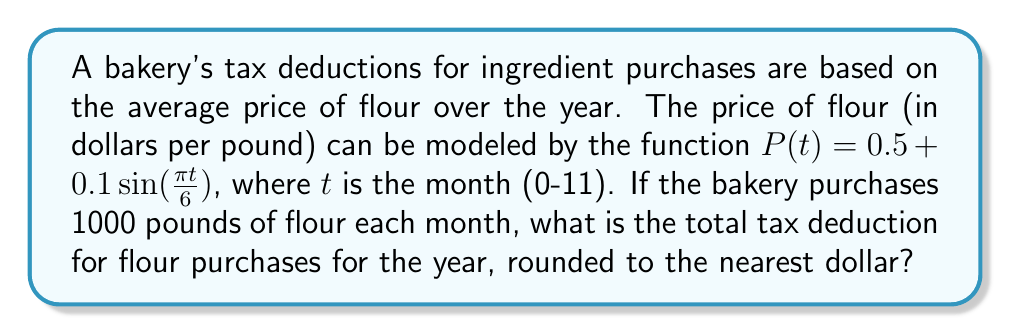What is the answer to this math problem? To solve this problem, we need to follow these steps:

1) First, we need to calculate the average price of flour over the year:
   $$\text{Average Price} = \frac{1}{12}\sum_{t=0}^{11} P(t)$$

2) We can expand this:
   $$\frac{1}{12}\sum_{t=0}^{11} (0.5 + 0.1\sin(\frac{\pi t}{6}))$$

3) Simplify:
   $$\frac{1}{12}(12 \cdot 0.5 + 0.1\sum_{t=0}^{11} \sin(\frac{\pi t}{6}))$$

4) The sum of sine over a full period is zero, so:
   $$\frac{1}{12}(12 \cdot 0.5 + 0) = 0.5$$

5) So the average price is $0.50 per pound.

6) The bakery purchases 1000 pounds each month, so for the year:
   $$12 \cdot 1000 = 12000\text{ pounds}$$

7) The total cost (and thus tax deduction) is:
   $$12000 \cdot 0.50 = 6000\text{ dollars}$$

8) The question asks for the nearest dollar, but our result is already a whole number.
Answer: $6000 